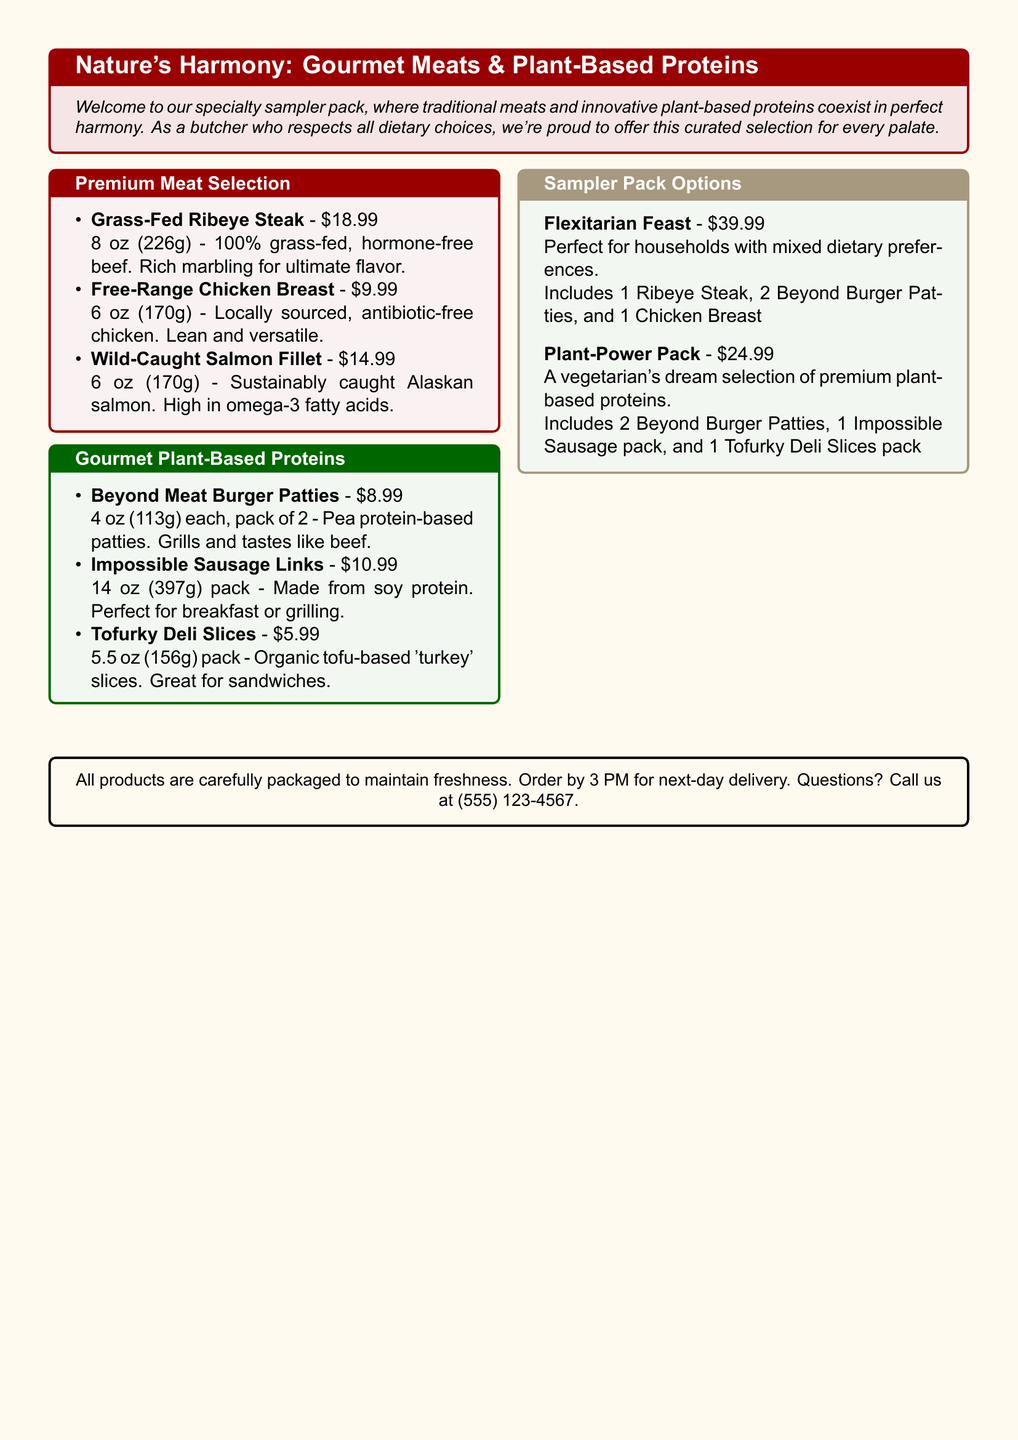what is the price of the Grass-Fed Ribeye Steak? The price of the Grass-Fed Ribeye Steak is listed in the Premium Meat Selection section.
Answer: $18.99 how many ounces is the Wild-Caught Salmon Fillet? The Wild-Caught Salmon Fillet is mentioned in ounces under the Premium Meat Selection heading.
Answer: 6 oz what plant-based protein is suggested for breakfast? The document specifies a plant-based protein option suitable for breakfast among the Gourmet Plant-Based Proteins.
Answer: Impossible Sausage Links what does the Flexitarian Feast sampler pack include? The contents of the Flexitarian Feast sampler pack are listed in the Sampler Pack Options section.
Answer: 1 Ribeye Steak, 2 Beyond Burger Patties, and 1 Chicken Breast how much does the Plant-Power Pack cost? The cost of the Plant-Power Pack is specified in the Sampler Pack Options section.
Answer: $24.99 which protein is made from organic tofu? The document lists plant-based proteins, and this particular one is identified within the Gourmet Plant-Based Proteins section.
Answer: Tofurky Deli Slices what type of meat is the Free-Range Chicken Breast? The document describes the Free-Range Chicken Breast in the Premium Meat Selection with its sourcing details.
Answer: Antibiotic-free chicken what is the total weight of the Impossible Sausage Links pack? The total weight is provided in ounces in the document.
Answer: 14 oz how late can orders be placed for next-day delivery? The document specifies the cut-off time for next-day delivery in the final box.
Answer: 3 PM 